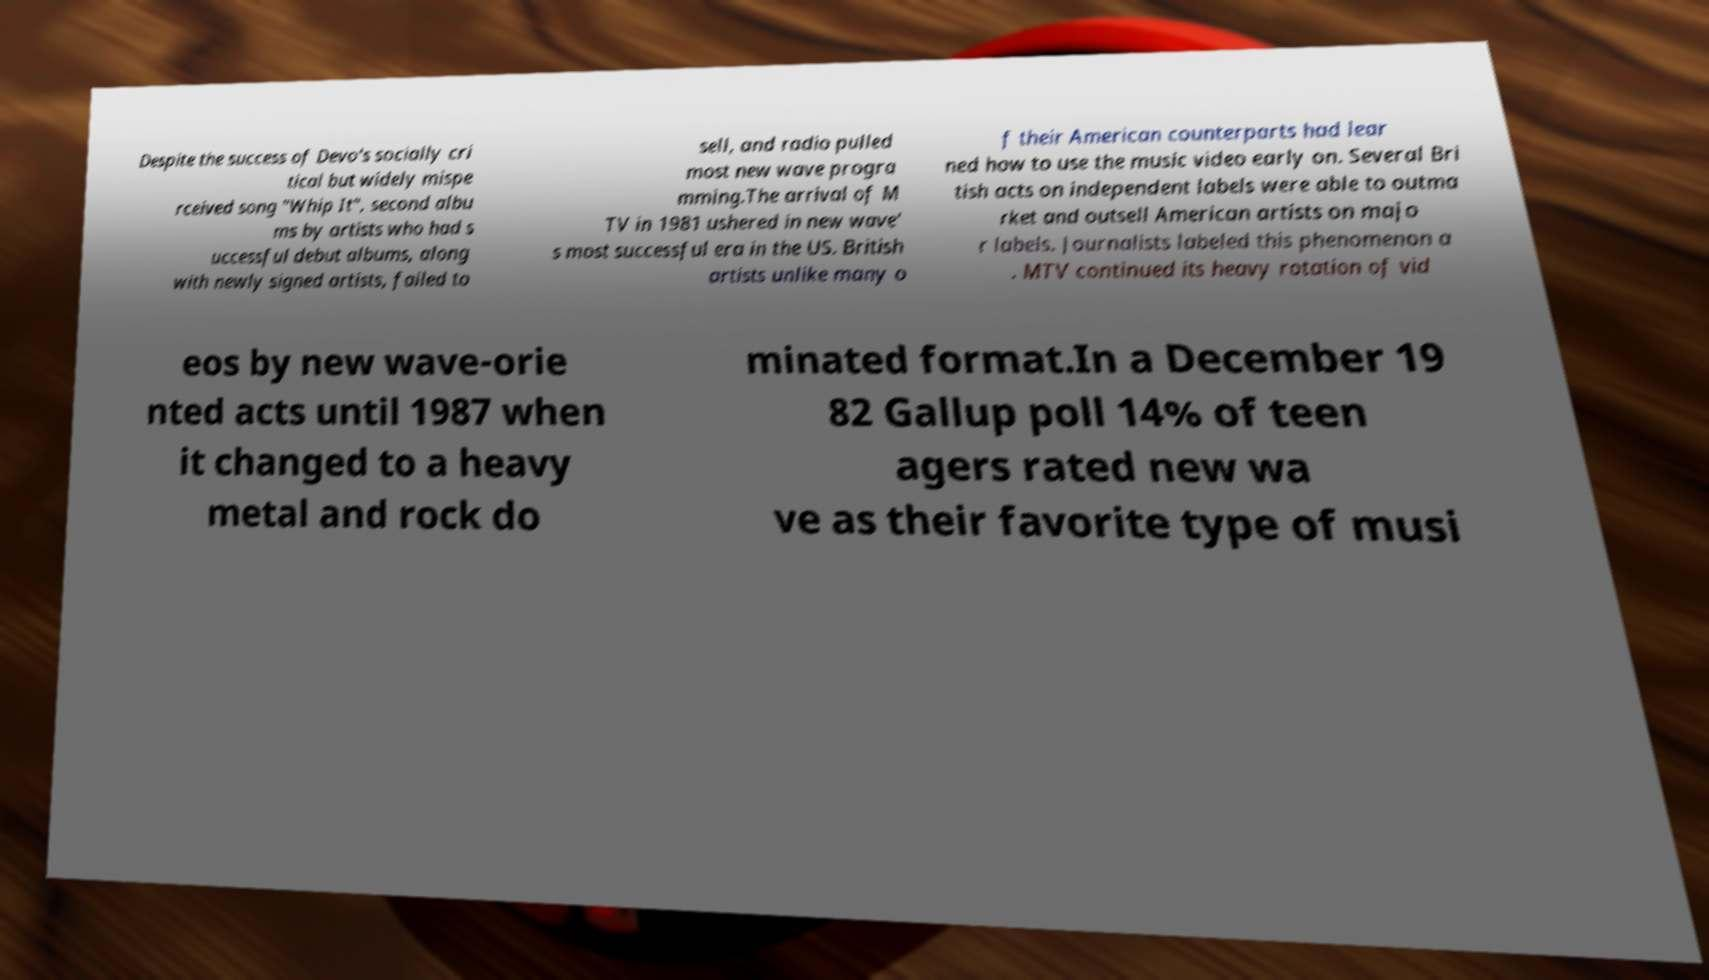Please read and relay the text visible in this image. What does it say? Despite the success of Devo's socially cri tical but widely mispe rceived song "Whip It", second albu ms by artists who had s uccessful debut albums, along with newly signed artists, failed to sell, and radio pulled most new wave progra mming.The arrival of M TV in 1981 ushered in new wave' s most successful era in the US. British artists unlike many o f their American counterparts had lear ned how to use the music video early on. Several Bri tish acts on independent labels were able to outma rket and outsell American artists on majo r labels. Journalists labeled this phenomenon a . MTV continued its heavy rotation of vid eos by new wave-orie nted acts until 1987 when it changed to a heavy metal and rock do minated format.In a December 19 82 Gallup poll 14% of teen agers rated new wa ve as their favorite type of musi 